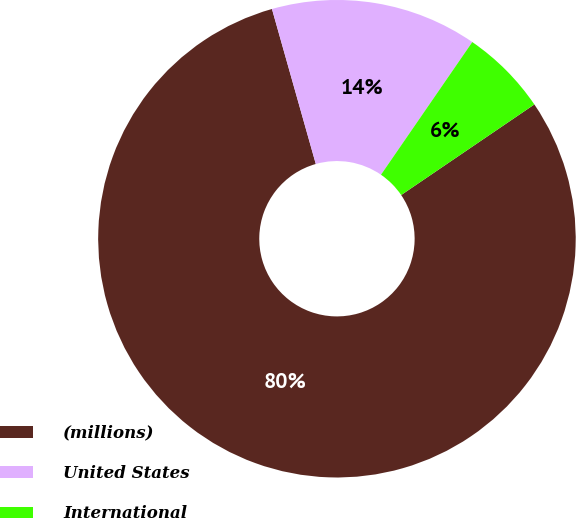<chart> <loc_0><loc_0><loc_500><loc_500><pie_chart><fcel>(millions)<fcel>United States<fcel>International<nl><fcel>80.12%<fcel>13.98%<fcel>5.9%<nl></chart> 